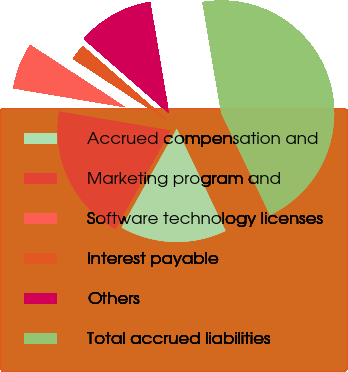<chart> <loc_0><loc_0><loc_500><loc_500><pie_chart><fcel>Accrued compensation and<fcel>Marketing program and<fcel>Software technology licenses<fcel>Interest payable<fcel>Others<fcel>Total accrued liabilities<nl><fcel>15.22%<fcel>19.56%<fcel>6.55%<fcel>2.22%<fcel>10.89%<fcel>45.56%<nl></chart> 